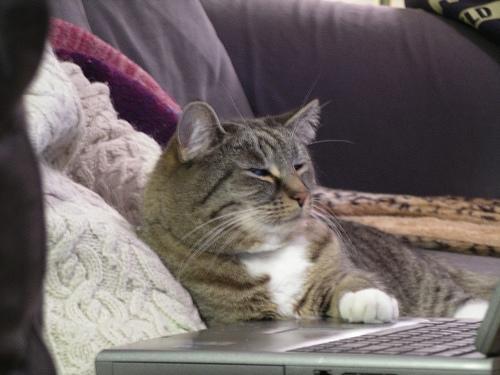How many animals are there?
Give a very brief answer. 1. 